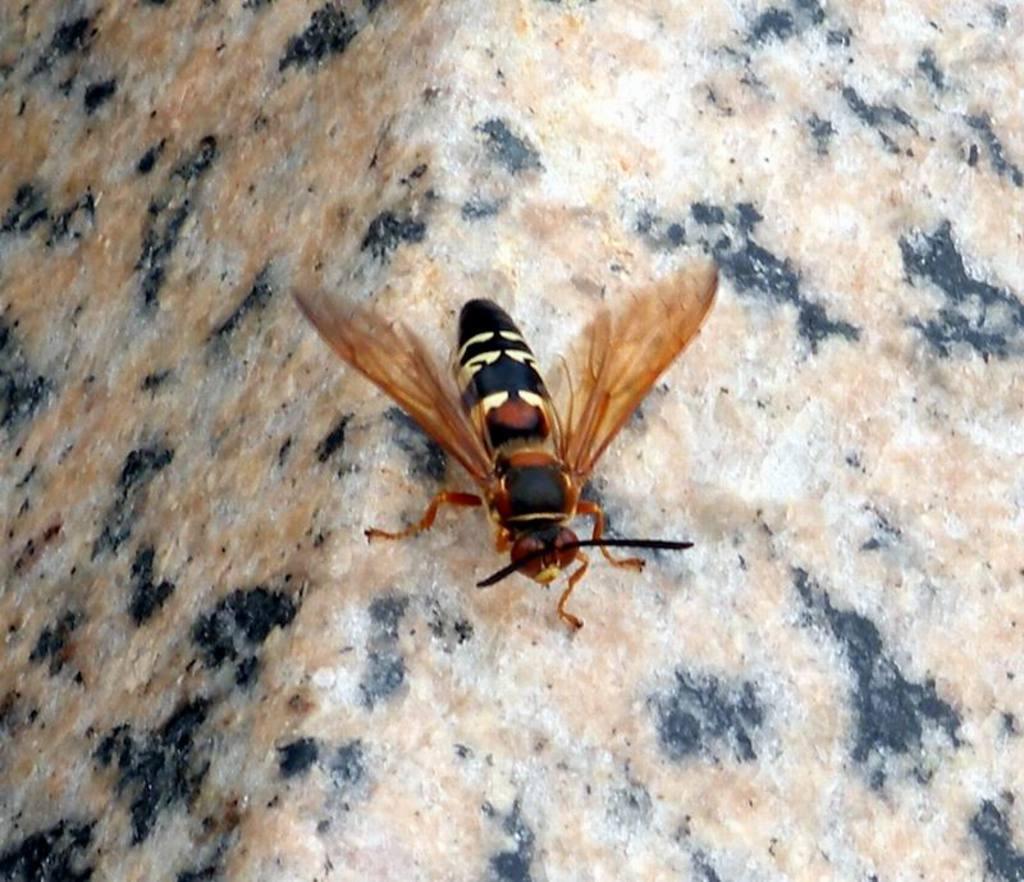How would you summarize this image in a sentence or two? This image consists of a fly in brown color. At the bottom, there is a rock. 